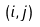Convert formula to latex. <formula><loc_0><loc_0><loc_500><loc_500>( i , j )</formula> 